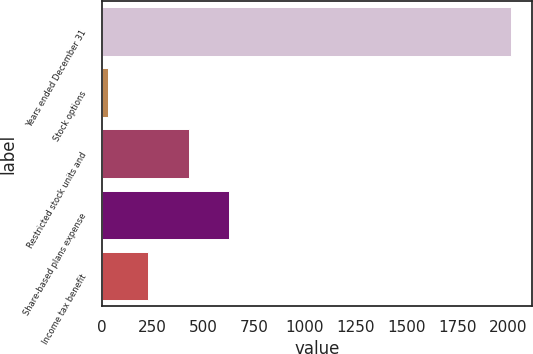<chart> <loc_0><loc_0><loc_500><loc_500><bar_chart><fcel>Years ended December 31<fcel>Stock options<fcel>Restricted stock units and<fcel>Share-based plans expense<fcel>Income tax benefit<nl><fcel>2015<fcel>30<fcel>427<fcel>625.5<fcel>228.5<nl></chart> 